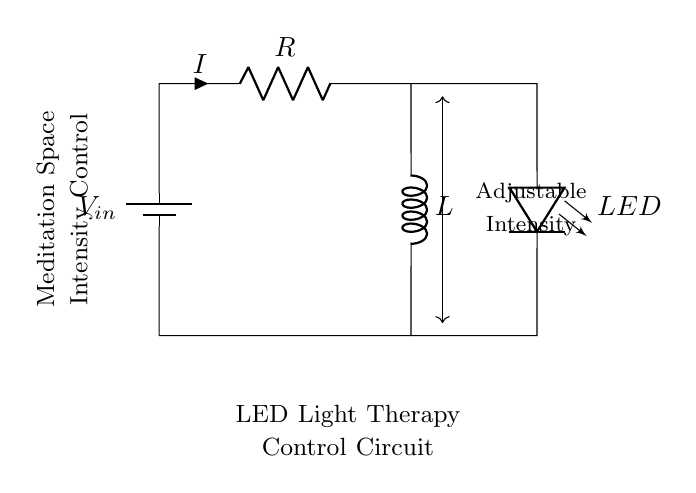What is the main purpose of this circuit? The main purpose of this circuit is to control the intensity of LED light therapy in a meditation space. The LED is used as a therapy light that can have its brightness adjusted through the resistor and inductor configuration.
Answer: controlling LED intensity What component is used for adjusting the current? The resistor is the component used to adjust the current. Its resistance value can be varied to change the current flowing through the circuit, affecting the brightness of the LED.
Answer: resistor What type of circuit is this? This circuit is a Resistor-Inductor (RL) circuit. It contains a resistor and an inductor in series, which is a common configuration for controlling current dynamics in circuits.
Answer: RL circuit What is the role of the inductor in this circuit? The inductor serves to smooth out the changes in current when the circuit is switched on or off, providing a more gradual change in LED brightness and enhancing the effectiveness of the light therapy.
Answer: smoothing current changes What happens to the LED brightness if the resistance is increased? If the resistance is increased, the current through the LED decreases, resulting in dimmer LED brightness. Higher resistance restricts the flow of current, leading to less power being delivered to the LED.
Answer: decreases brightness How can the LED intensity be adjusted? The LED intensity can be adjusted by changing the value of the resistor in the circuit. By using a variable resistor or potentiometer, users can control the resistance, therefore adjusting the current and LED brightness.
Answer: adjusting the resistor 